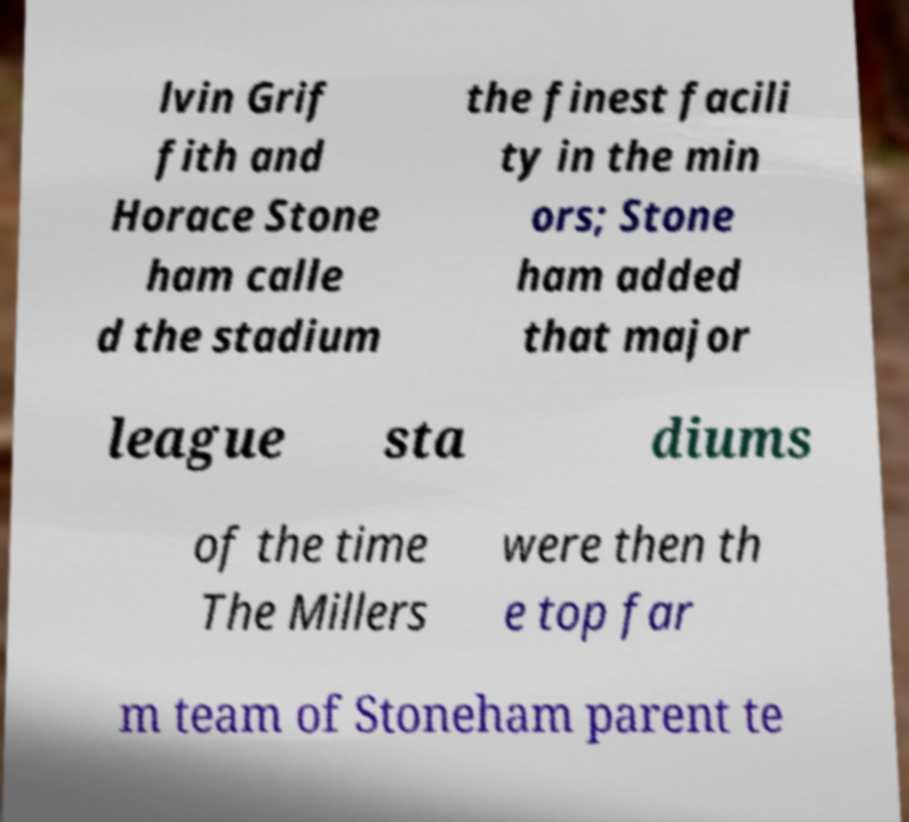Could you extract and type out the text from this image? lvin Grif fith and Horace Stone ham calle d the stadium the finest facili ty in the min ors; Stone ham added that major league sta diums of the time The Millers were then th e top far m team of Stoneham parent te 